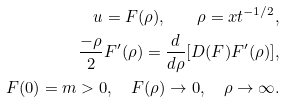<formula> <loc_0><loc_0><loc_500><loc_500>u = F ( \rho ) , \quad \rho = x t ^ { - 1 / 2 } , \\ \frac { - \rho } { 2 } F ^ { \prime } ( \rho ) = \frac { d } { d \rho } [ D ( F ) F ^ { \prime } ( \rho ) ] , \\ F ( 0 ) = m > 0 , \quad F ( \rho ) \to 0 , \quad \rho \to \infty .</formula> 